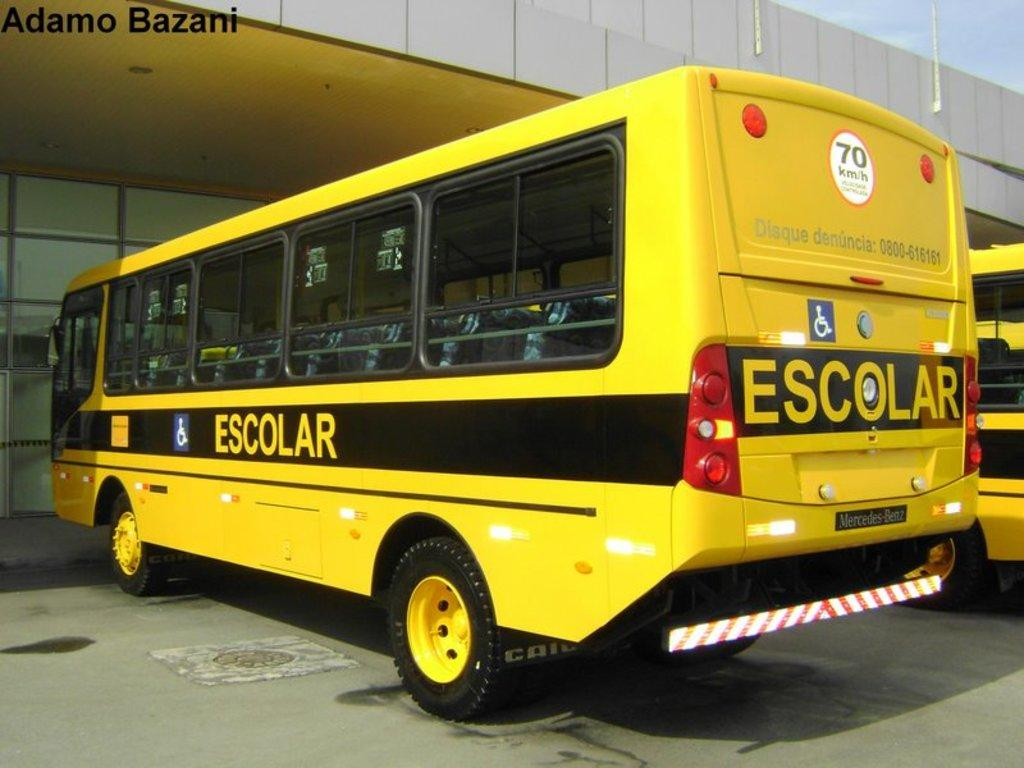How many buses are present in the image? There are two buses in the image. What can be seen on the buses? There is writing on the buses. What type of sock is hanging from the bus in the image? There is no sock present in the image; it only features two buses with writing on them. 